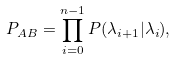<formula> <loc_0><loc_0><loc_500><loc_500>P _ { A B } = \prod _ { i = 0 } ^ { n - 1 } P ( \lambda _ { i + 1 } | \lambda _ { i } ) ,</formula> 